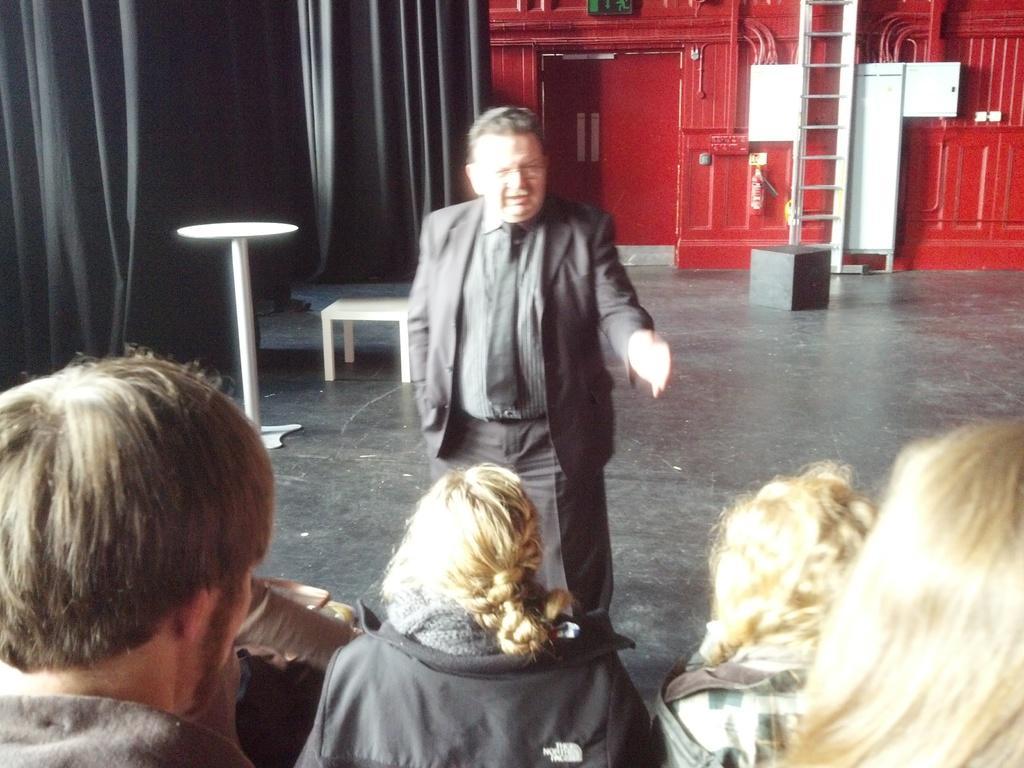In one or two sentences, can you explain what this image depicts? This image consists of so many persons at the bottom. In the middle there is a man standing. He is wearing a blazer and tie. There is a table on the left side. There is a curtain at the top. It is in black color. 